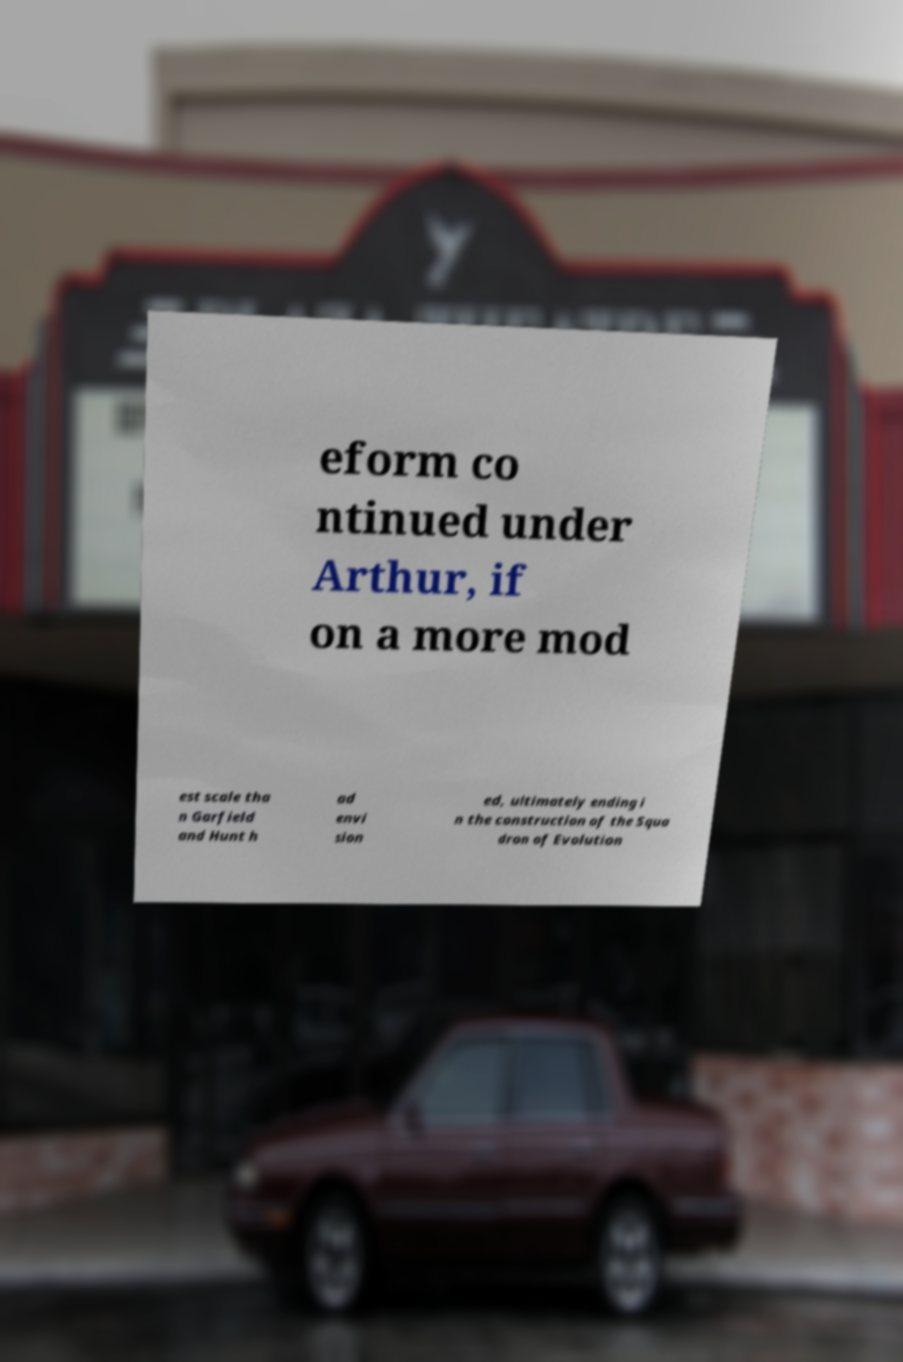I need the written content from this picture converted into text. Can you do that? eform co ntinued under Arthur, if on a more mod est scale tha n Garfield and Hunt h ad envi sion ed, ultimately ending i n the construction of the Squa dron of Evolution 